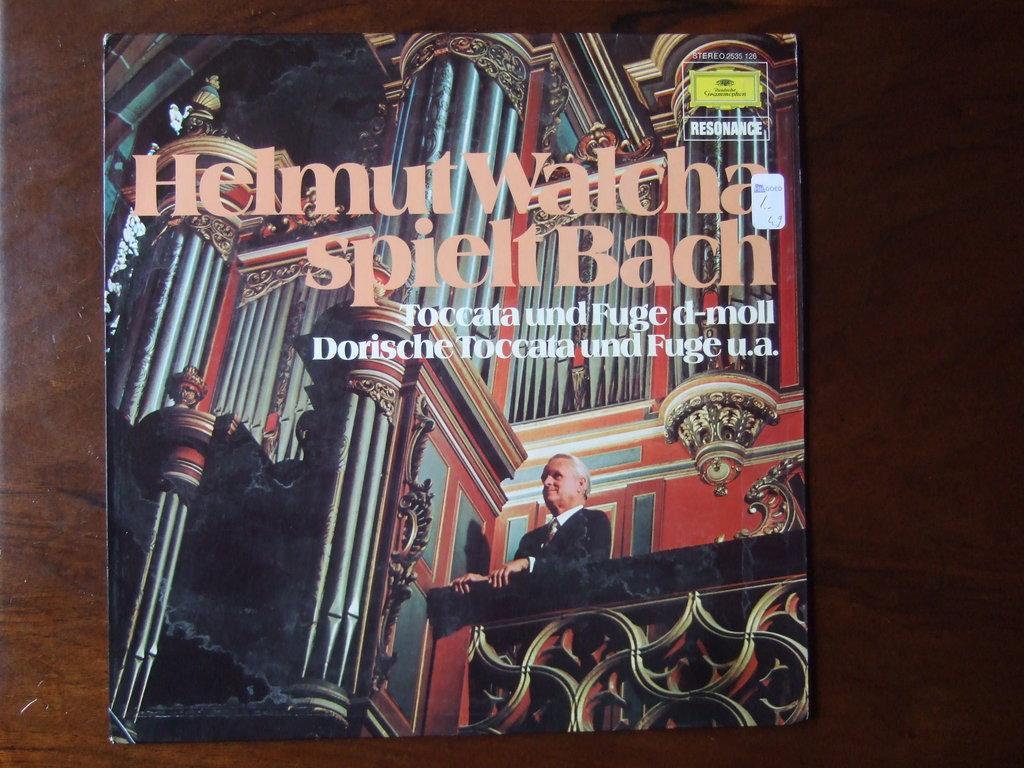Provide a one-sentence caption for the provided image. The album artwork for Helmut Walcha spielt Bach features a man in a black suit. 